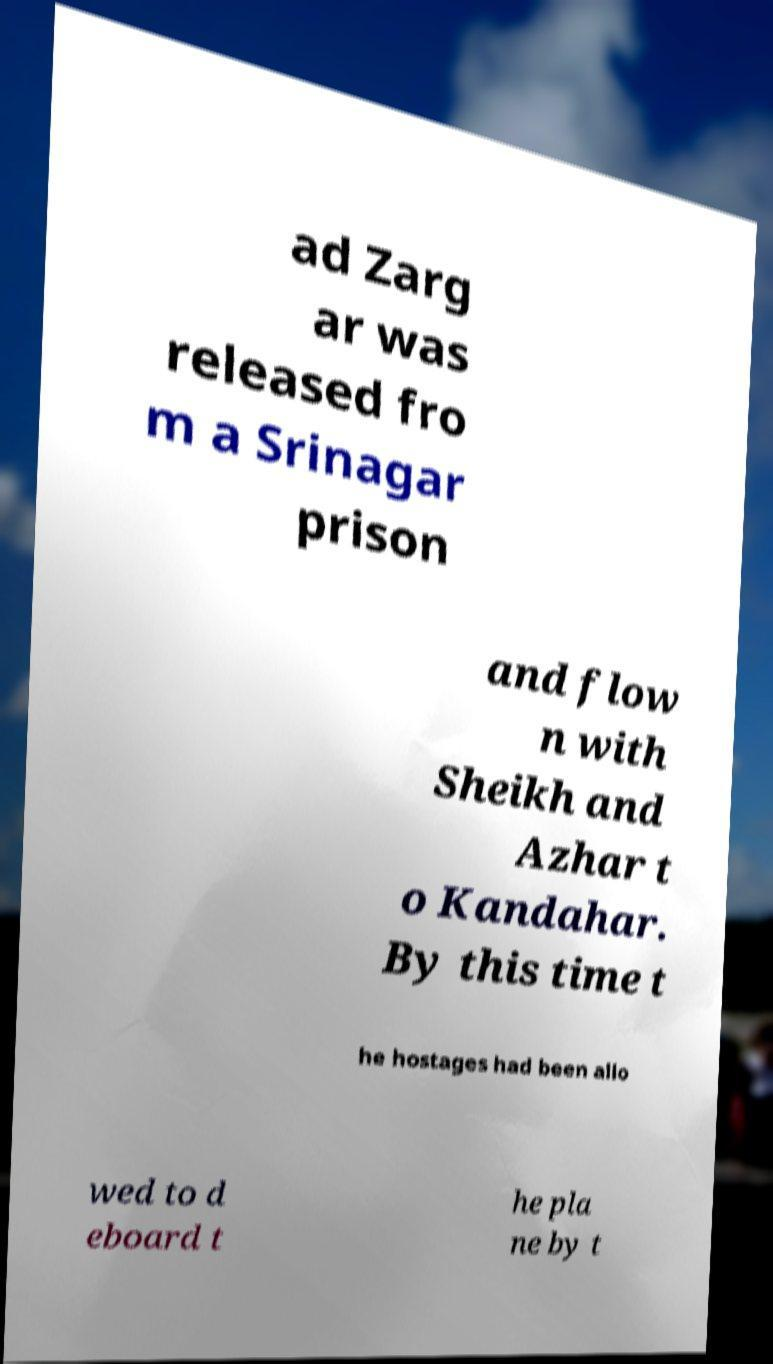Please read and relay the text visible in this image. What does it say? ad Zarg ar was released fro m a Srinagar prison and flow n with Sheikh and Azhar t o Kandahar. By this time t he hostages had been allo wed to d eboard t he pla ne by t 